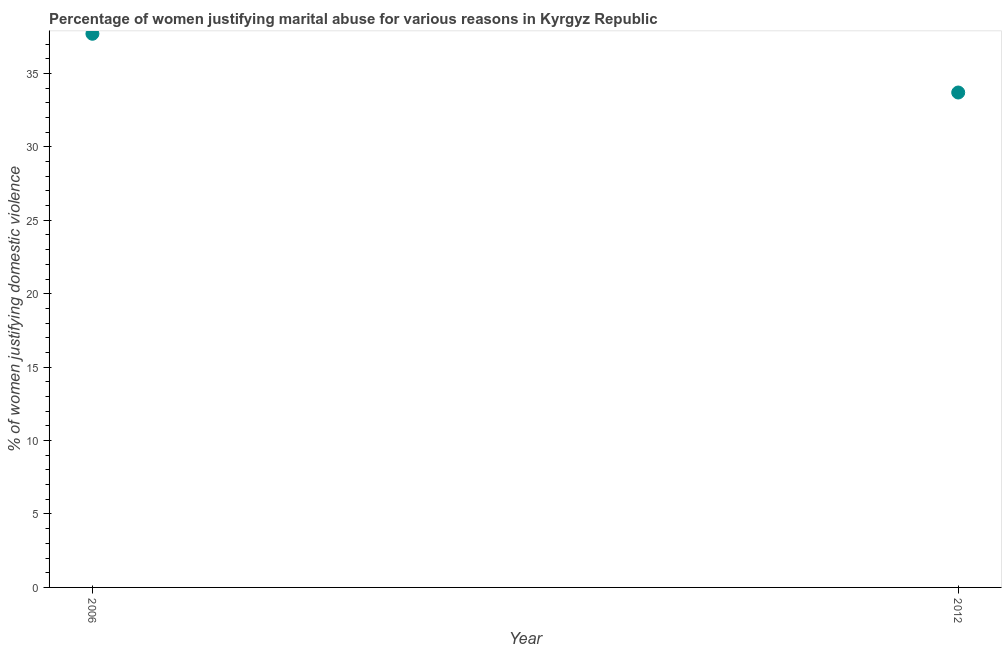What is the percentage of women justifying marital abuse in 2006?
Offer a very short reply. 37.7. Across all years, what is the maximum percentage of women justifying marital abuse?
Ensure brevity in your answer.  37.7. Across all years, what is the minimum percentage of women justifying marital abuse?
Your answer should be compact. 33.7. In which year was the percentage of women justifying marital abuse maximum?
Give a very brief answer. 2006. In which year was the percentage of women justifying marital abuse minimum?
Give a very brief answer. 2012. What is the sum of the percentage of women justifying marital abuse?
Your answer should be very brief. 71.4. What is the average percentage of women justifying marital abuse per year?
Provide a short and direct response. 35.7. What is the median percentage of women justifying marital abuse?
Your response must be concise. 35.7. In how many years, is the percentage of women justifying marital abuse greater than 4 %?
Ensure brevity in your answer.  2. What is the ratio of the percentage of women justifying marital abuse in 2006 to that in 2012?
Ensure brevity in your answer.  1.12. What is the difference between two consecutive major ticks on the Y-axis?
Keep it short and to the point. 5. Does the graph contain any zero values?
Your answer should be compact. No. Does the graph contain grids?
Provide a short and direct response. No. What is the title of the graph?
Make the answer very short. Percentage of women justifying marital abuse for various reasons in Kyrgyz Republic. What is the label or title of the Y-axis?
Offer a terse response. % of women justifying domestic violence. What is the % of women justifying domestic violence in 2006?
Your response must be concise. 37.7. What is the % of women justifying domestic violence in 2012?
Your answer should be compact. 33.7. What is the ratio of the % of women justifying domestic violence in 2006 to that in 2012?
Offer a terse response. 1.12. 